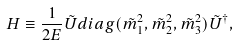Convert formula to latex. <formula><loc_0><loc_0><loc_500><loc_500>H \equiv \frac { 1 } { 2 E } \tilde { U } d i a g ( \tilde { m } _ { 1 } ^ { 2 } , \tilde { m } _ { 2 } ^ { 2 } , \tilde { m } _ { 3 } ^ { 2 } ) \tilde { U } ^ { \dagger } ,</formula> 